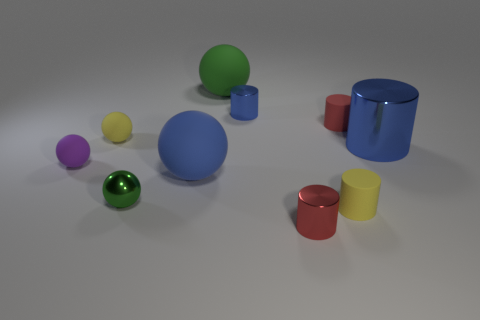Subtract 1 balls. How many balls are left? 4 Subtract all tiny blue cylinders. How many cylinders are left? 4 Subtract all yellow spheres. How many spheres are left? 4 Subtract all green cylinders. Subtract all blue spheres. How many cylinders are left? 5 Add 3 big red metallic cubes. How many big red metallic cubes exist? 3 Subtract 2 blue cylinders. How many objects are left? 8 Subtract all large brown spheres. Subtract all big blue rubber spheres. How many objects are left? 9 Add 4 large spheres. How many large spheres are left? 6 